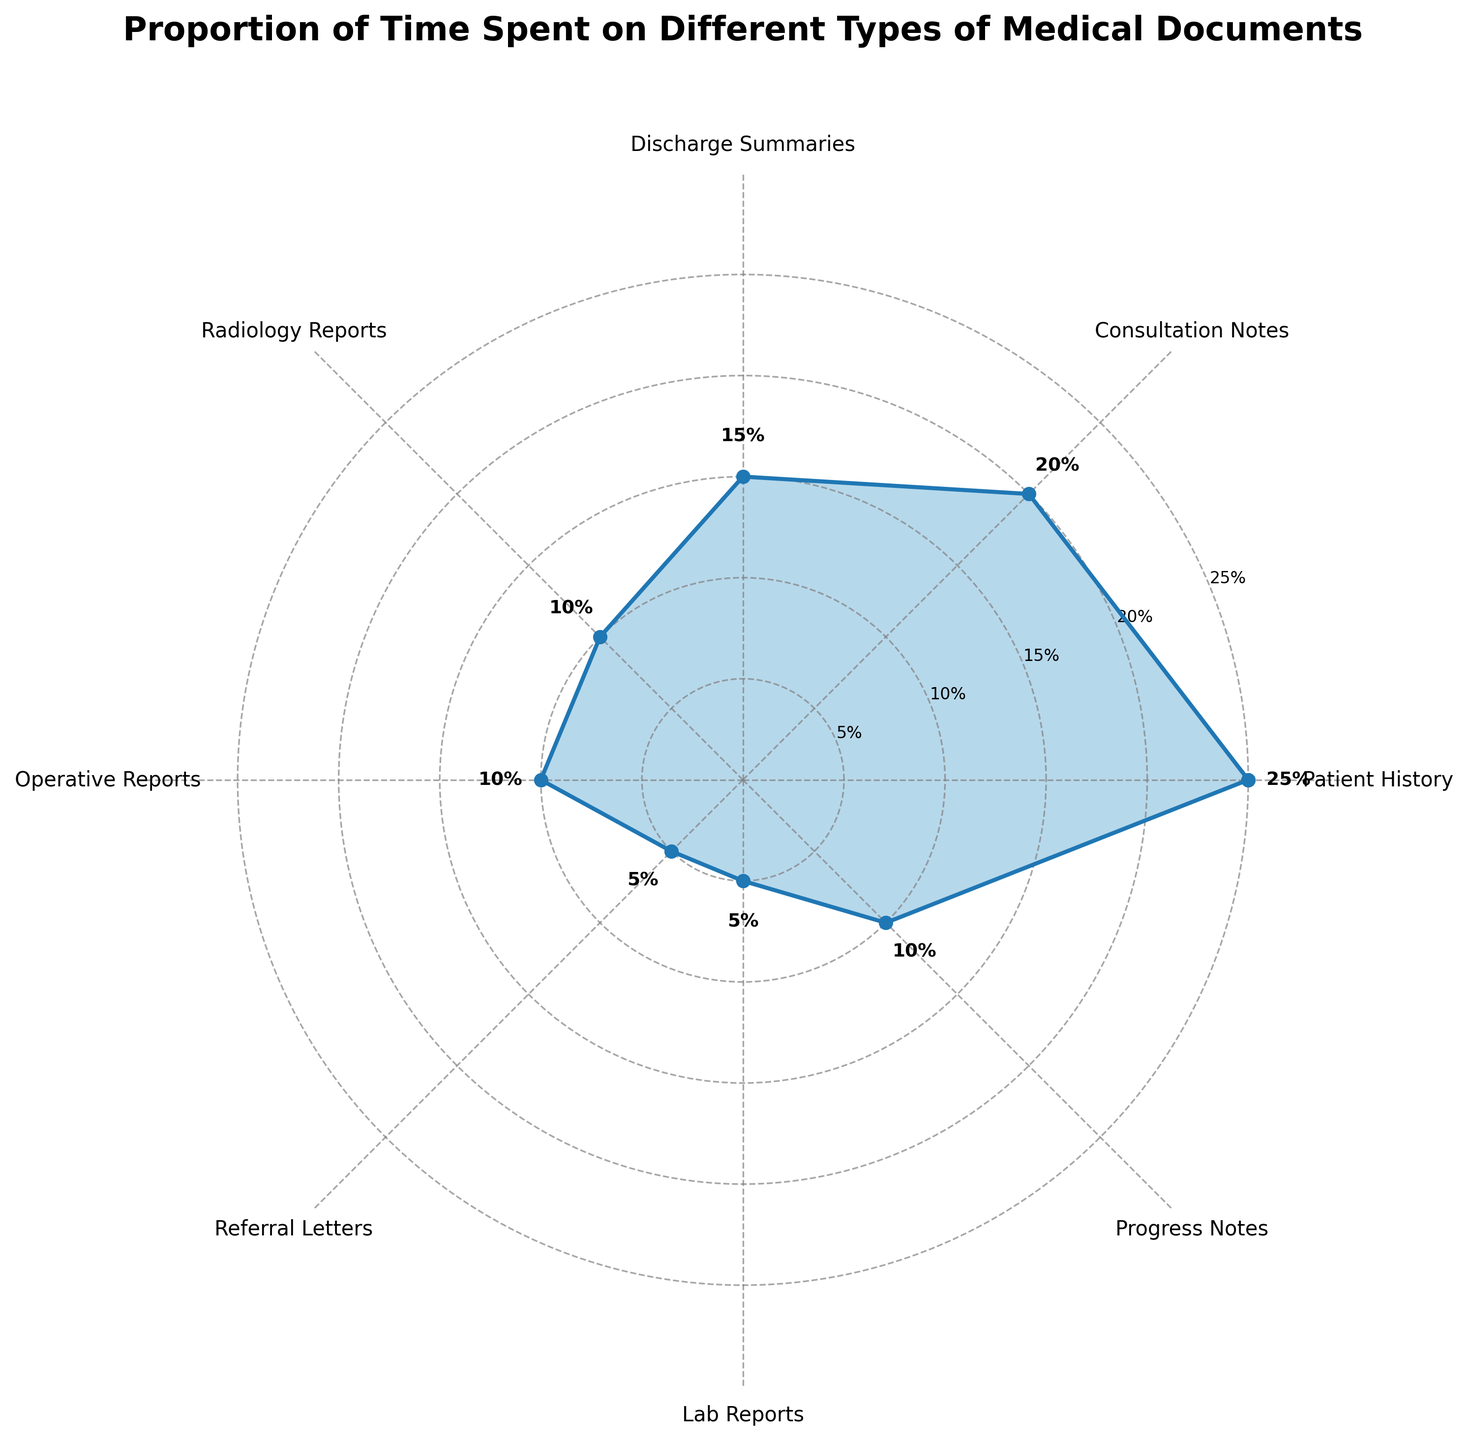What is the title of the chart? The title is found at the top of the chart, generally in larger font, and it describes what the chart is about.
Answer: Proportion of Time Spent on Different Types of Medical Documents How many document types are represented in the chart? Count the number of unique category labels present around the perimeter of the polar chart.
Answer: Eight Which document type has the highest proportion of time spent? Locate the segment with the largest filled area and confirm by reading the percentage next to the segment label.
Answer: Patient History Which document types have the same proportion of time spent? Compare the values next to the segment labels to find which ones are equal.
Answer: Radiology Reports, Operative Reports, and Progress Notes What is the combined proportion of time spent on Consultation Notes and Discharge Summaries? Add the proportion values of Consultation Notes and Discharge Summaries given in the chart.
Answer: 35% How much more time is spent on Patient History compared to Referral Letters? Subtract the proportion value of Referral Letters from that of Patient History.
Answer: 20% What proportion of time is spent on Lab Reports? Locate the segment for Lab Reports and read the proportion value.
Answer: 5% Which document type has the smallest proportion of time spent? Identify the smallest segment by area and verify with the corresponding percentage label.
Answer: Referral Letters and Lab Reports What is the average proportion of time spent on Radiology Reports, Operative Reports, and Progress Notes? Sum the proportion values of Radiology Reports, Operative Reports, and Progress Notes, and then divide by 3.
Answer: 10% Which document type is represented by the blue color filled area other than angles labeled? Identify the color representing these areas in the legend or by visual inspection. All segments should appear blue because the plot uses a single color for the filled area.
Answer: All document types 